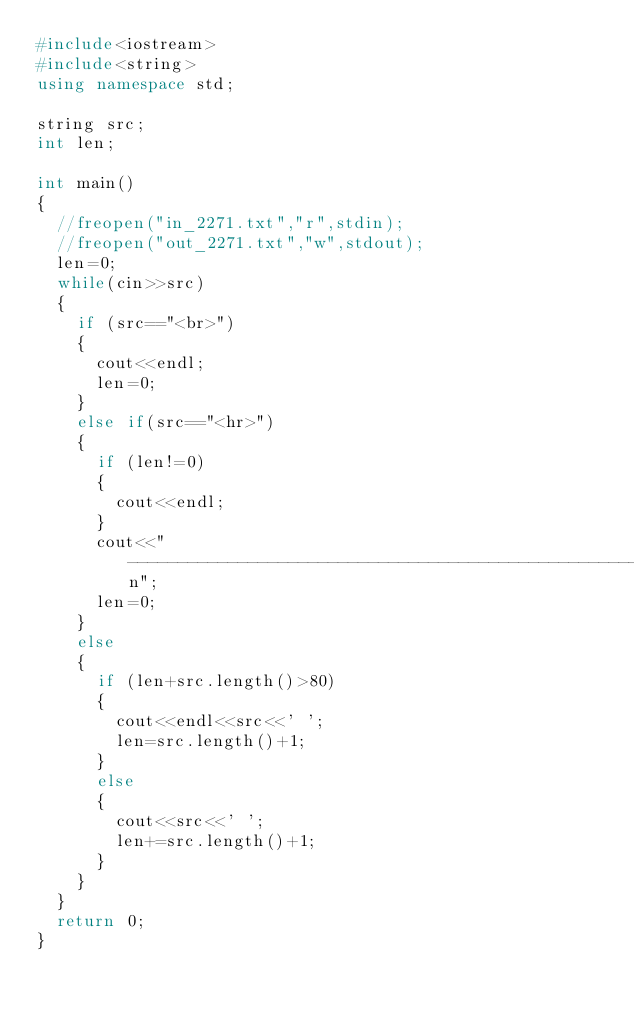Convert code to text. <code><loc_0><loc_0><loc_500><loc_500><_C++_>#include<iostream>
#include<string>
using namespace std;

string src;
int len;

int main()
{
	//freopen("in_2271.txt","r",stdin);
	//freopen("out_2271.txt","w",stdout);
	len=0;
	while(cin>>src)
	{
		if (src=="<br>")
		{
			cout<<endl;
			len=0;
		}
		else if(src=="<hr>")
		{
			if (len!=0)
			{
				cout<<endl;
			}
			cout<<"--------------------------------------------------------------------------------\n";
			len=0;
		}
		else
		{
			if (len+src.length()>80)
			{
				cout<<endl<<src<<' ';
				len=src.length()+1;
			}
			else
			{
				cout<<src<<' ';
				len+=src.length()+1;
			}
		}
	}
	return 0;
}
</code> 